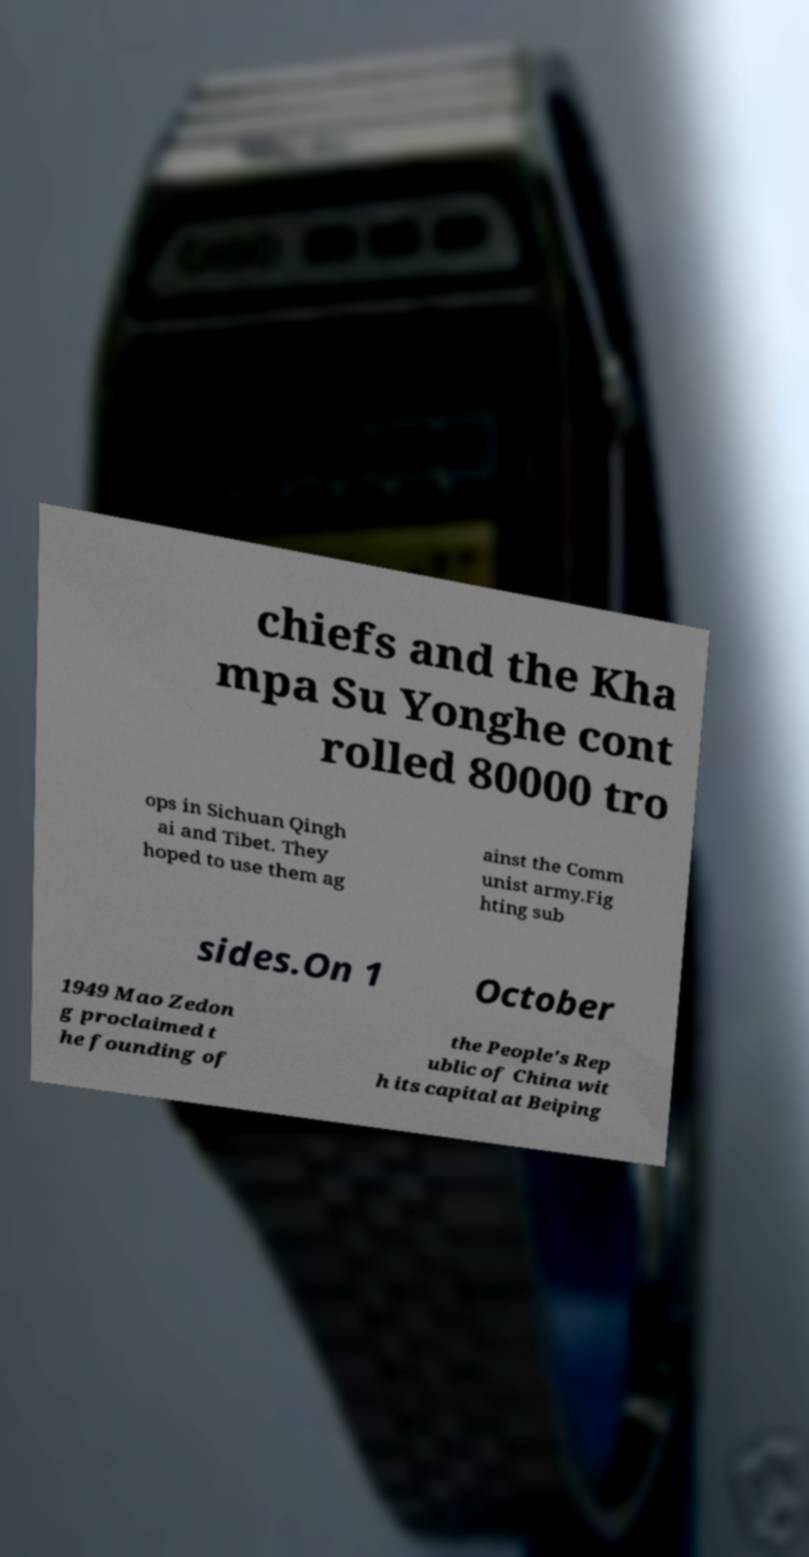Please read and relay the text visible in this image. What does it say? chiefs and the Kha mpa Su Yonghe cont rolled 80000 tro ops in Sichuan Qingh ai and Tibet. They hoped to use them ag ainst the Comm unist army.Fig hting sub sides.On 1 October 1949 Mao Zedon g proclaimed t he founding of the People's Rep ublic of China wit h its capital at Beiping 